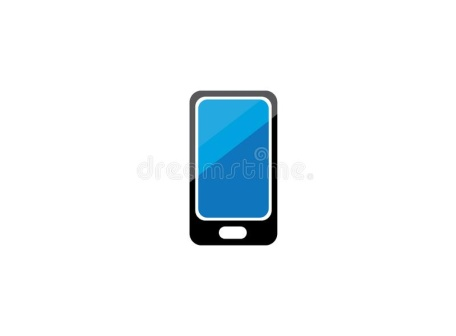Write a short sci-fi story where this phone plays a crucial role. In the year 2050, humanity had expanded its reach to the stars. Amidst the vastness of space, the crew of the Arkadia was on a mission to explore a newly discovered planet. Among their advanced tools was the X-Phone, a sleek, black device with a glowing blue screen. Unknown to many, this phone was more than just communication technology; it was the key to unraveling the mysteries of alien civilizations. One day, while surveying the planet’s surface, the crew stumbled upon an ancient alien artifact. Despite their best efforts, they couldn't decipher its meaning. Frustrated and out of options, Captain Elena scanned the artifact with the X-Phone. The blue screen flickered, and the device began projecting holographic images and decoding the alien script. The crew watched in awe as the X-Phone translated the symbols into directions leading to an underground city. This city held advanced technologies that surpassed all human knowledge. Thanks to the X-Phone, the crew not only unlocked new worlds of possibilities but also ensured humanity's survival and progress in the galaxy. 